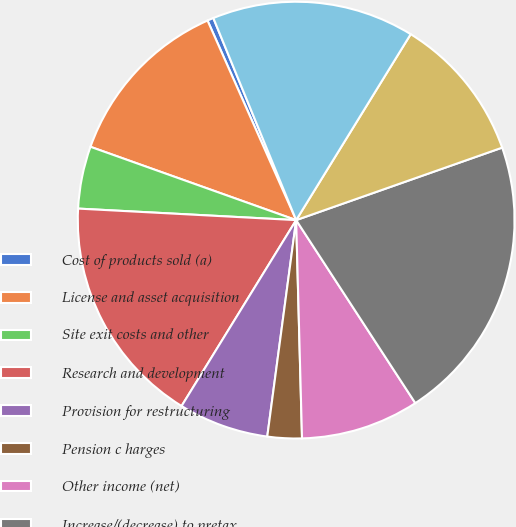Convert chart to OTSL. <chart><loc_0><loc_0><loc_500><loc_500><pie_chart><fcel>Cost of products sold (a)<fcel>License and asset acquisition<fcel>Site exit costs and other<fcel>Research and development<fcel>Provision for restructuring<fcel>Pension c harges<fcel>Other income (net)<fcel>Increase/(decrease) to pretax<fcel>Income taxes<fcel>Increase/(decrease) to net<nl><fcel>0.46%<fcel>12.9%<fcel>4.61%<fcel>17.05%<fcel>6.68%<fcel>2.54%<fcel>8.76%<fcel>21.2%<fcel>10.83%<fcel>14.98%<nl></chart> 